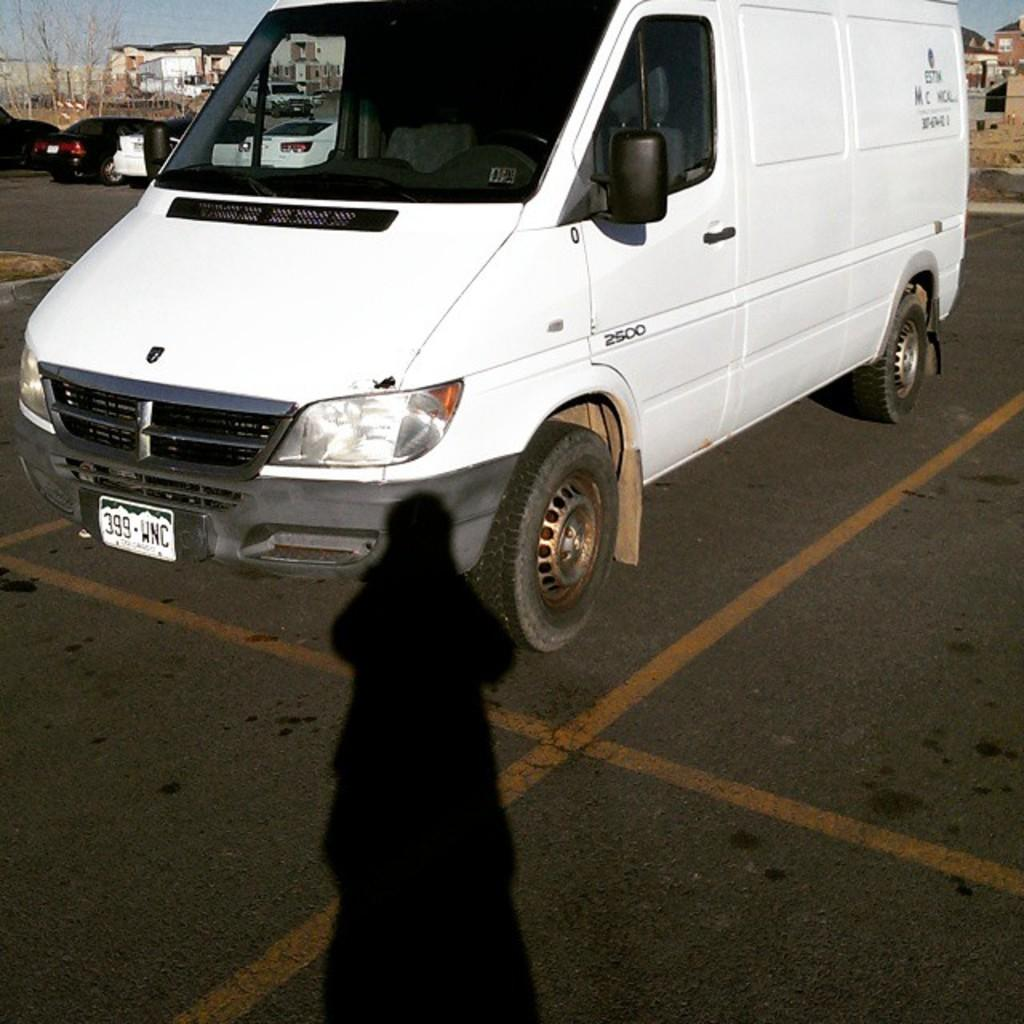<image>
Provide a brief description of the given image. A white van carries the license plate 399 WNC. 